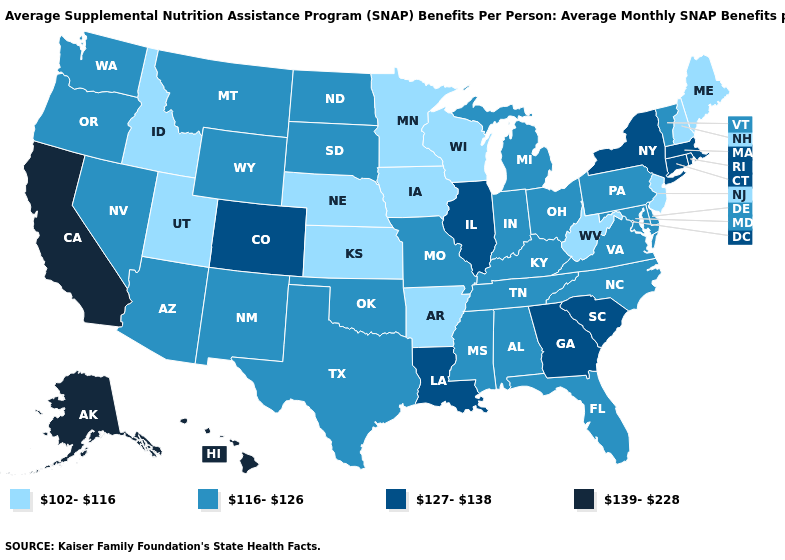Among the states that border Utah , which have the highest value?
Short answer required. Colorado. Which states have the lowest value in the USA?
Concise answer only. Arkansas, Idaho, Iowa, Kansas, Maine, Minnesota, Nebraska, New Hampshire, New Jersey, Utah, West Virginia, Wisconsin. What is the value of New Mexico?
Answer briefly. 116-126. What is the value of Alaska?
Be succinct. 139-228. Name the states that have a value in the range 127-138?
Give a very brief answer. Colorado, Connecticut, Georgia, Illinois, Louisiana, Massachusetts, New York, Rhode Island, South Carolina. Among the states that border North Carolina , which have the highest value?
Concise answer only. Georgia, South Carolina. What is the lowest value in the USA?
Be succinct. 102-116. What is the highest value in the Northeast ?
Be succinct. 127-138. Which states hav the highest value in the South?
Short answer required. Georgia, Louisiana, South Carolina. What is the value of Maryland?
Write a very short answer. 116-126. Is the legend a continuous bar?
Give a very brief answer. No. Name the states that have a value in the range 139-228?
Short answer required. Alaska, California, Hawaii. What is the value of New Mexico?
Keep it brief. 116-126. Among the states that border Arkansas , does Oklahoma have the highest value?
Short answer required. No. 